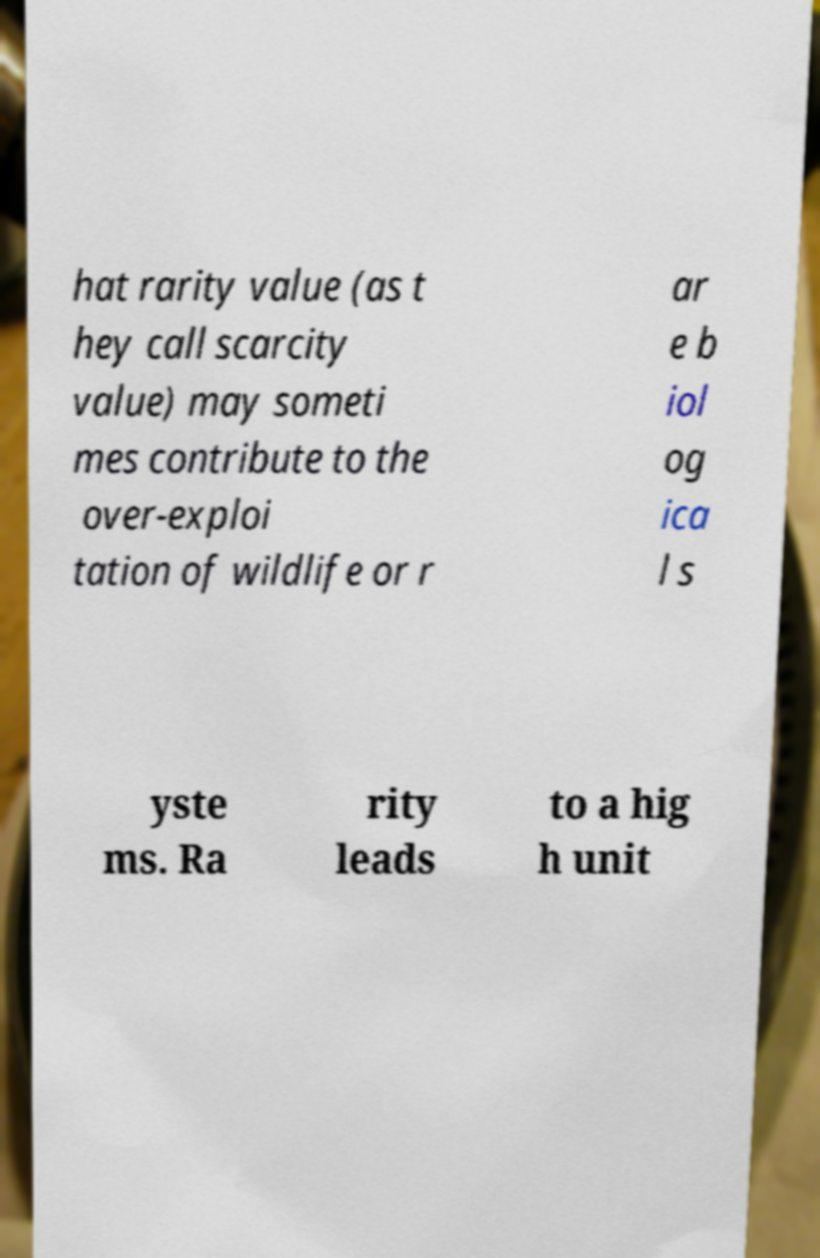Could you assist in decoding the text presented in this image and type it out clearly? hat rarity value (as t hey call scarcity value) may someti mes contribute to the over-exploi tation of wildlife or r ar e b iol og ica l s yste ms. Ra rity leads to a hig h unit 